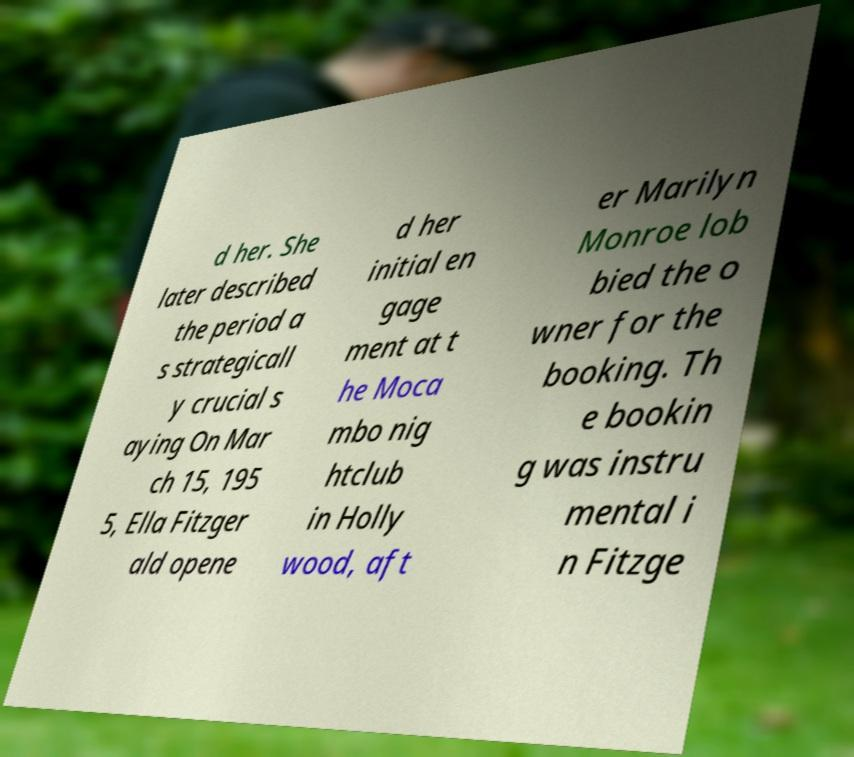There's text embedded in this image that I need extracted. Can you transcribe it verbatim? d her. She later described the period a s strategicall y crucial s aying On Mar ch 15, 195 5, Ella Fitzger ald opene d her initial en gage ment at t he Moca mbo nig htclub in Holly wood, aft er Marilyn Monroe lob bied the o wner for the booking. Th e bookin g was instru mental i n Fitzge 